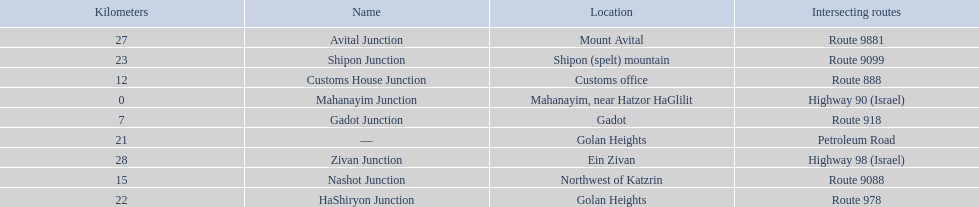What are all of the junction names? Mahanayim Junction, Gadot Junction, Customs House Junction, Nashot Junction, —, HaShiryon Junction, Shipon Junction, Avital Junction, Zivan Junction. What are their locations in kilometers? 0, 7, 12, 15, 21, 22, 23, 27, 28. Between shipon and avital, whicih is nashot closer to? Shipon Junction. 